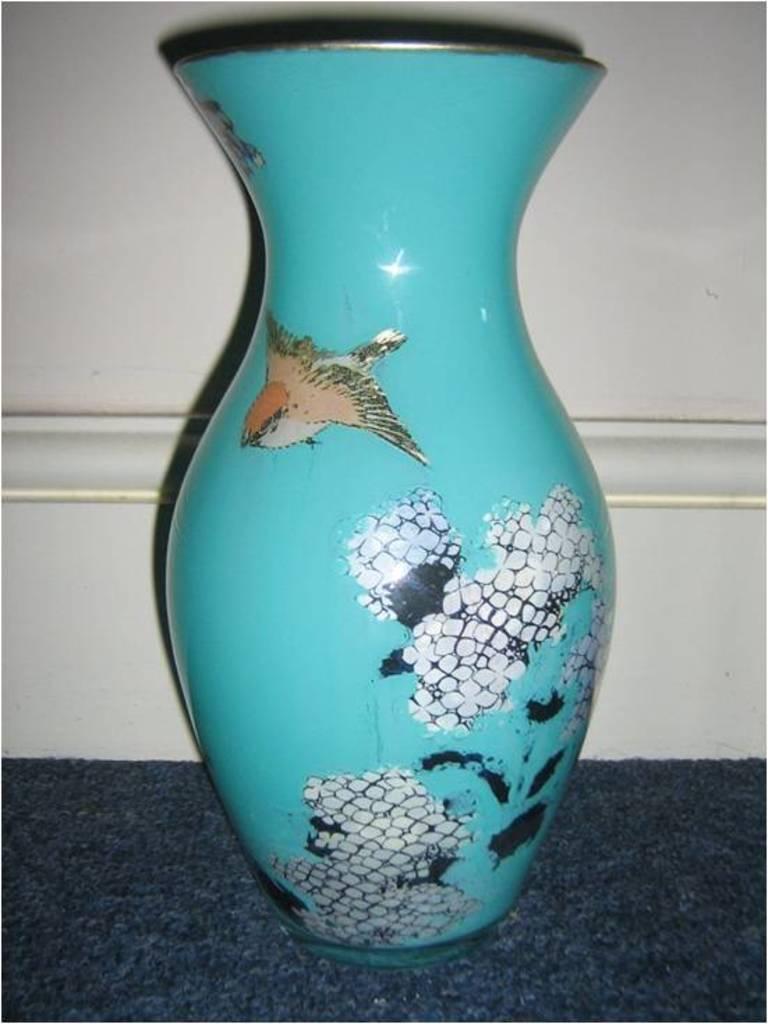How would you summarize this image in a sentence or two? In this image I can see a blue color vase. Background is in white color. 